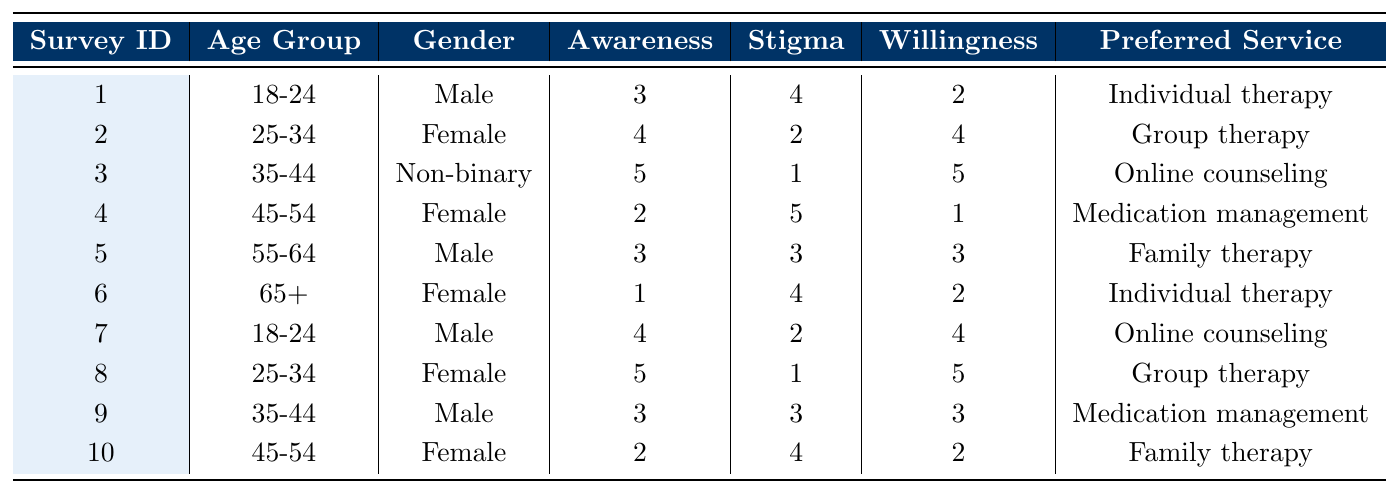What is the awareness level of the youngest age group (18-24)? The table shows that there are two entries for the age group 18-24 with awareness scores of 3 and 4. Therefore, the awareness level is represented by these values.
Answer: 3 and 4 Which gender shows the highest average awareness of mental health services? To find the average awareness by gender, we add the awareness scores for each gender: Males (3 + 5 + 4 + 3 = 15, divided by 4 = 3.75), Females (4 + 2 + 1 + 4 = 11, divided by 5 = 2.2), and Non-binary (5 = single data). Thus, Males have the highest average awareness of 3.75.
Answer: Male What stigma level has the lowest score in the table? By examining the stigma level column, we see the scores listed are 4, 2, 1, 5, 3, 4, 2, 1, 3, 4. The lowest score is 1.
Answer: 1 Is there a preference for individual therapy among the participants? The preferred service types are listed in the table. To determine if individual therapy is preferred, we can count its occurrences: It appears twice out of the ten responses. So yes, there is some preference.
Answer: Yes What is the average willingness to seek help among all participants? We sum the willingness scores: (2 + 4 + 5 + 1 + 3 + 2 + 4 + 5 + 3 + 2 = 31). Since there are 10 participants, we find the average by dividing 31 by 10, which gives us 3.1.
Answer: 3.1 Which age group has the highest reported stigma level? Looking at the stigma levels, we see that the age groups and their levels are: 18-24 = 4, 25-34 = 2, 35-44 = 1, 45-54 = 5, 55-64 = 3, and 65+ = 4. The highest level is 5, which is reported by the 45-54 age group.
Answer: 45-54 What is the most common preferred service type among the participants? To find the most common preferred service type, we count the instances of each type listed: Individual therapy (2), Group therapy (3), Online counseling (2), Medication management (2), Family therapy (2). Group therapy is the most common with 3 occurrences.
Answer: Group therapy Are all participants who have a negative previous experience willing to seek help? From the table, we see that participants with negative previous experience (35-44 and 65+) have willingness scores of 5 and 2, respectively. Since one participant is willing and another is not, not all with negative experiences are willing to seek help.
Answer: No What is the median stigma level among the participants? First, we need to arrange the stigma levels in order: 1, 1, 2, 2, 3, 3, 4, 4, 4, 5. The median is the average of the 5th and 6th values. Hence, (3 + 3) / 2 = 3.
Answer: 3 Which preferred outreach method is least mentioned in the survey? The outreach methods mentioned are Social media (2), Community events (2), Flyers (2), Local news (2), and Email newsletters (1). Email newsletters is the least mentioned with only 1 occurrence.
Answer: Email newsletters 